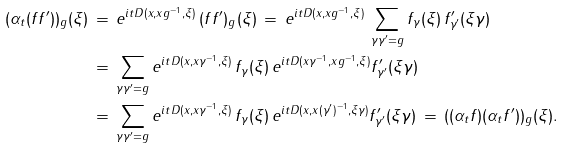<formula> <loc_0><loc_0><loc_500><loc_500>( \alpha _ { t } ( f f ^ { \prime } ) ) _ { g } ( \xi ) \, & = \, e ^ { i t D ( x , x g ^ { - 1 } , \xi ) } \, ( f f ^ { \prime } ) _ { g } ( \xi ) \, = \, e ^ { i t D ( x , x g ^ { - 1 } , \xi ) } \, \sum _ { \gamma \gamma ^ { \prime } = g } f _ { \gamma } ( \xi ) \, f ^ { \prime } _ { \gamma ^ { \prime } } ( \xi \gamma ) \\ & = \, \sum _ { \gamma \gamma ^ { \prime } = g } e ^ { i t D ( x , x \gamma ^ { - 1 } , \xi ) } \, f _ { \gamma } ( \xi ) \, e ^ { i t D ( x \gamma ^ { - 1 } , x g ^ { - 1 } , \xi ) } f ^ { \prime } _ { \gamma ^ { \prime } } ( \xi \gamma ) \\ & = \, \sum _ { \gamma \gamma ^ { \prime } = g } e ^ { i t D ( x , x \gamma ^ { - 1 } , \xi ) } \, f _ { \gamma } ( \xi ) \, e ^ { i t D ( x , x ( \gamma ^ { \prime } ) ^ { - 1 } , \xi \gamma ) } f ^ { \prime } _ { \gamma ^ { \prime } } ( \xi \gamma ) \, = \, ( ( \alpha _ { t } f ) ( \alpha _ { t } f ^ { \prime } ) ) _ { g } ( \xi ) .</formula> 